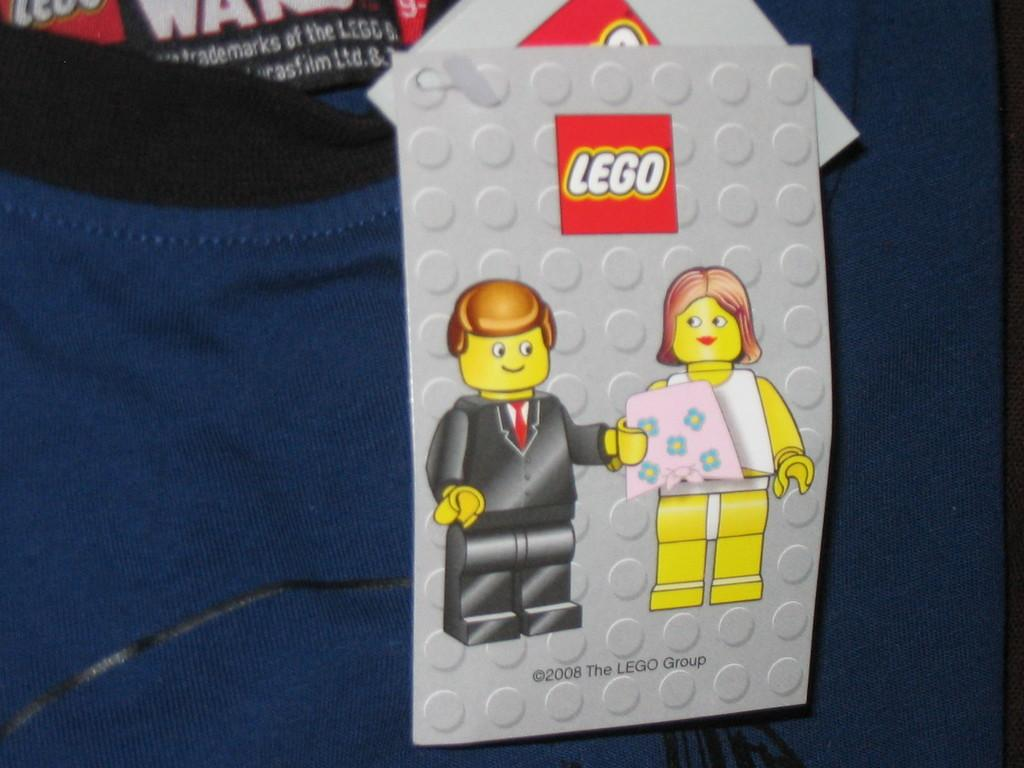<image>
Create a compact narrative representing the image presented. A Lego sign with a boy and a girl on it. 